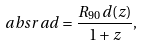Convert formula to latex. <formula><loc_0><loc_0><loc_500><loc_500>\ a b s r a d = \frac { R _ { 9 0 } d ( z ) } { 1 + z } ,</formula> 